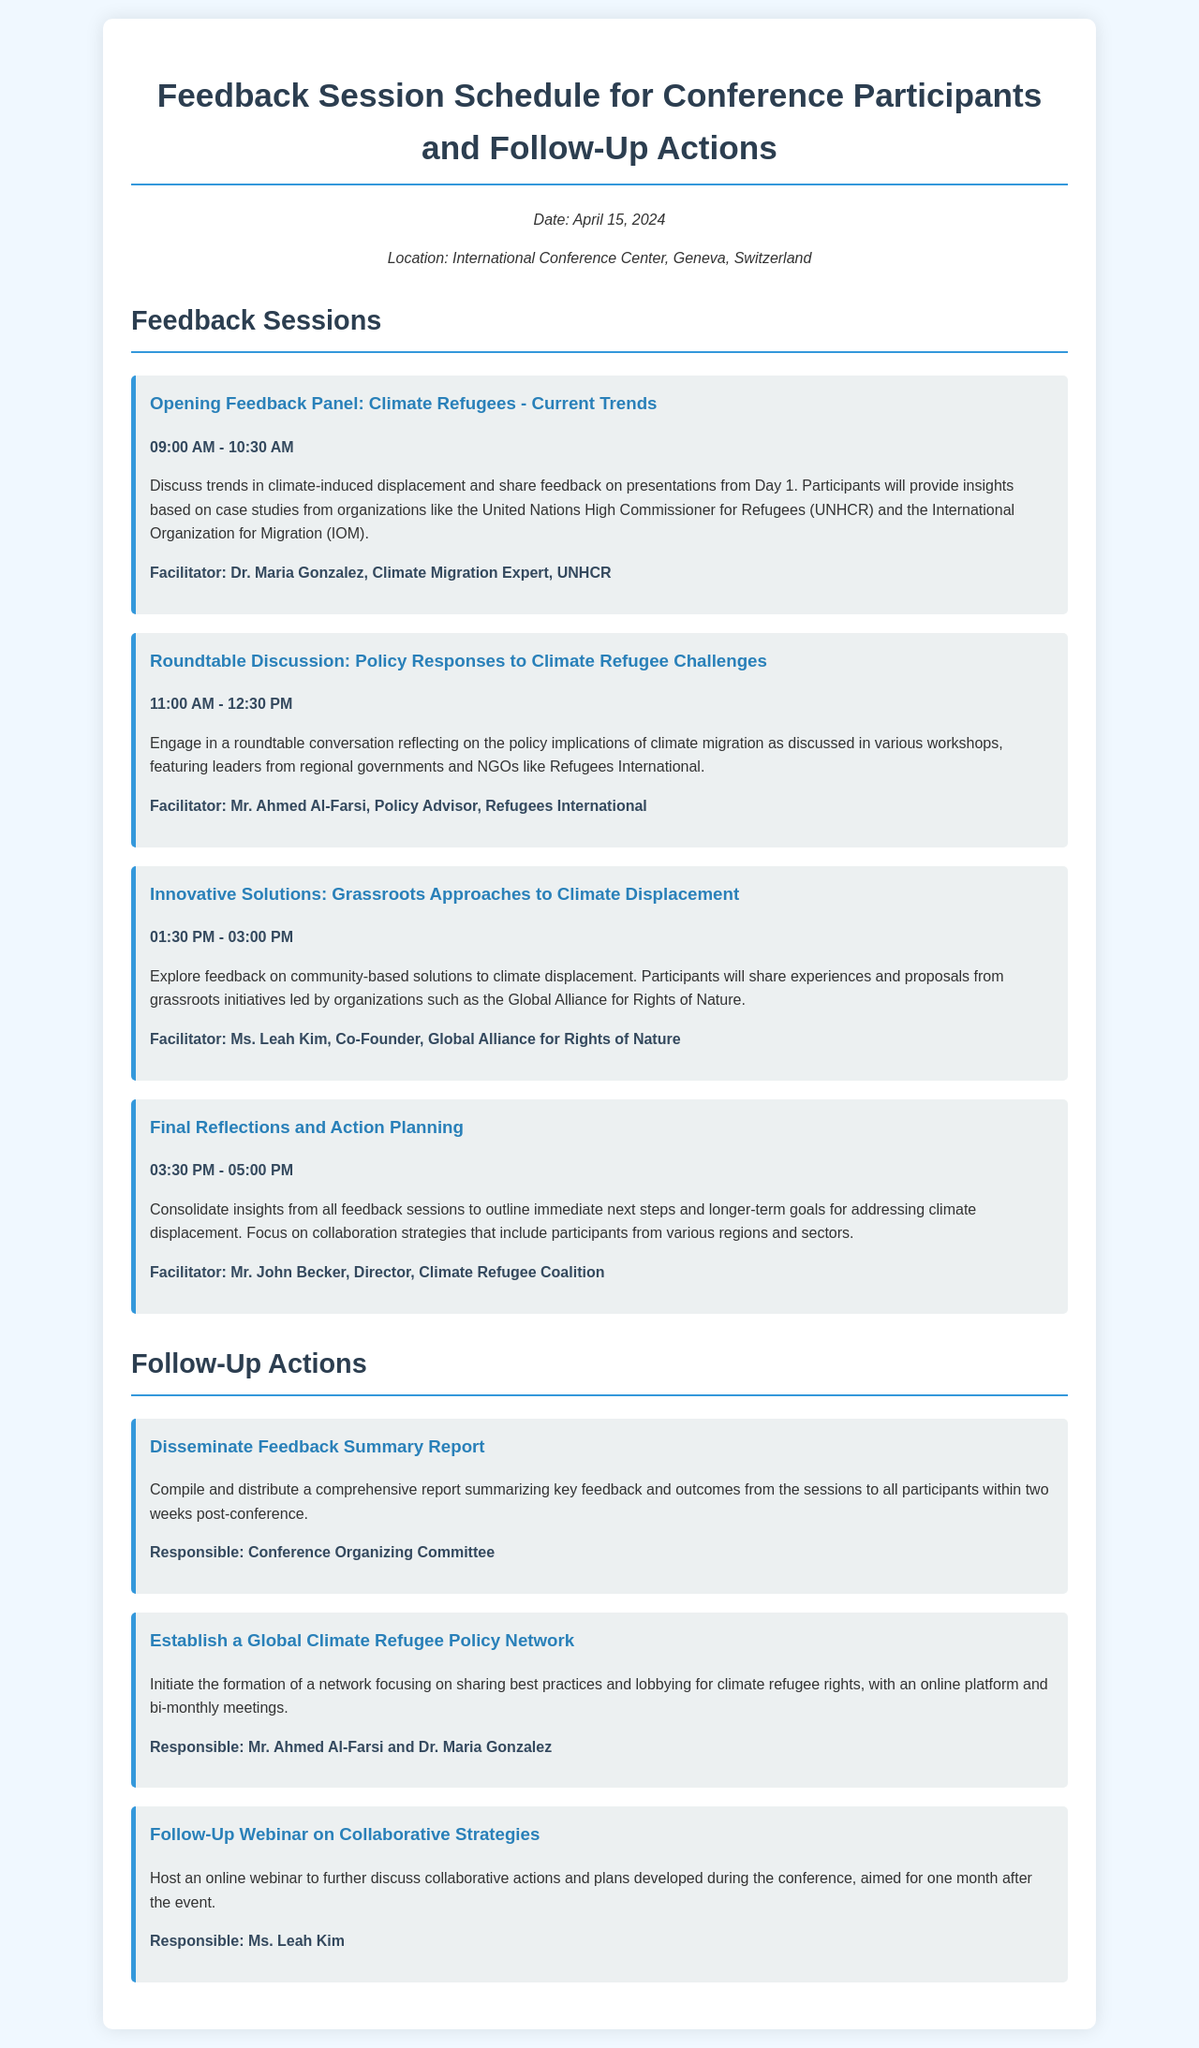What is the date of the conference? The date of the conference is explicitly mentioned in the document.
Answer: April 15, 2024 Who is the facilitator of the Opening Feedback Panel? The document lists the facilitator for each session.
Answer: Dr. Maria Gonzalez What time does the Roundtable Discussion commence? The start time of each session is specified in the schedule.
Answer: 11:00 AM What is one of the follow-up actions mentioned? Follow-up actions are detailed in a specific section of the document.
Answer: Disseminate Feedback Summary Report Who is responsible for establishing the Global Climate Refugee Policy Network? The responsible individuals for each action are listed in the document.
Answer: Mr. Ahmed Al-Farsi and Dr. Maria Gonzalez What is the end time of the Final Reflections and Action Planning session? The end time for each session is provided in the schedule.
Answer: 05:00 PM What organization is Dr. Maria Gonzalez associated with? Each facilitator's affiliation is noted under their name.
Answer: UNHCR How long is the Innovative Solutions session? The duration of each session can be deduced from the start and end times stated in the document.
Answer: 1.5 hours 